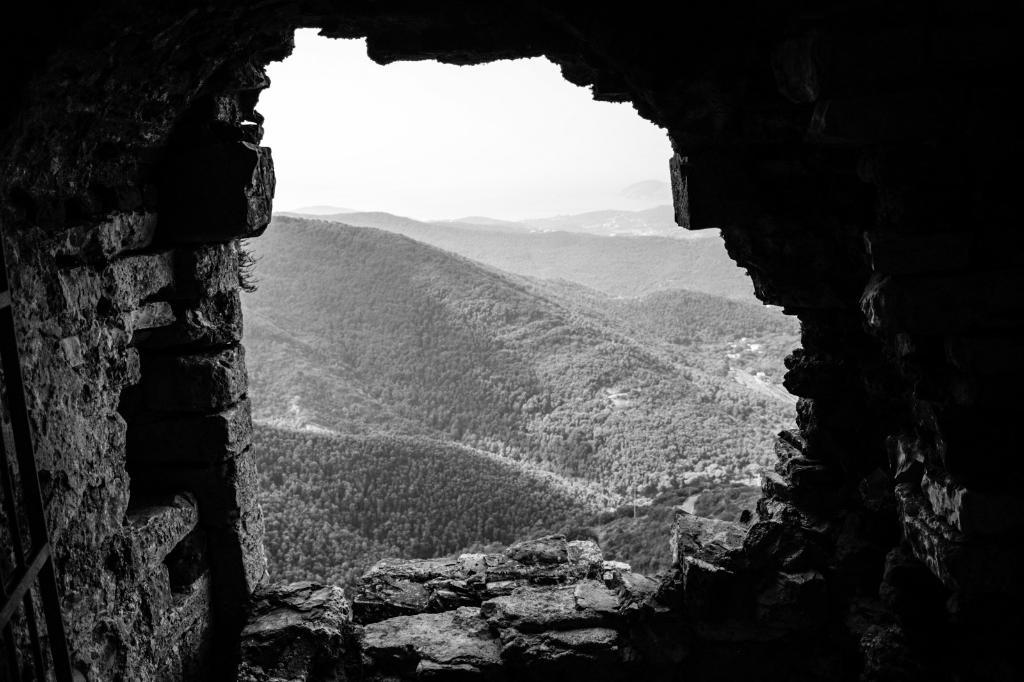What is the color scheme of the image? The image is black and white. What structure is located on the left side of the image? There is a wall on the left side of the image. What type of vegetation is visible behind the wall in the image? There are plenty of trees behind the wall in the image. What type of secretary can be seen working behind the wall in the image? There is no secretary present in the image; it only features a wall and trees in the background. 